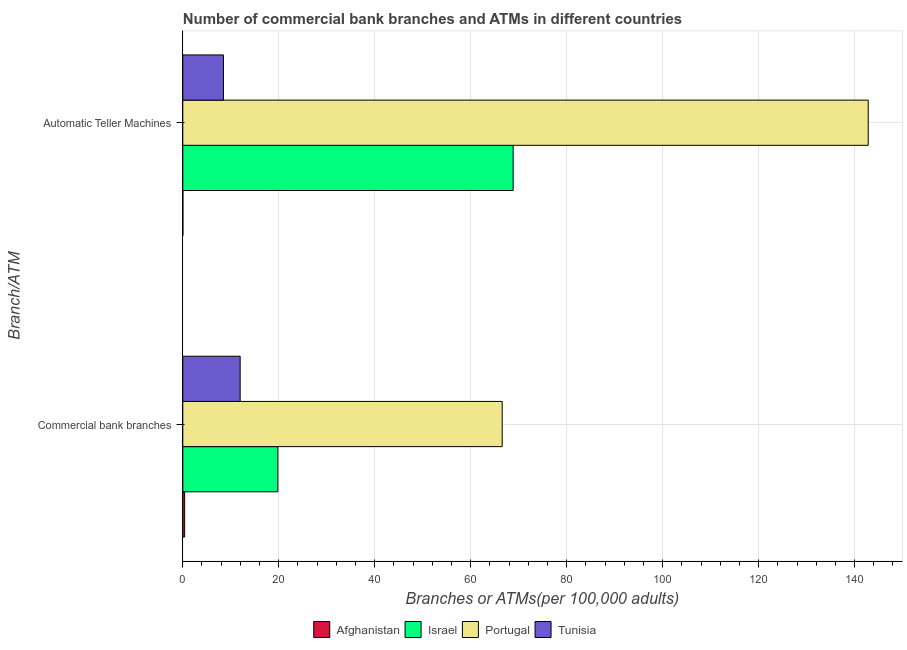Are the number of bars per tick equal to the number of legend labels?
Provide a succinct answer. Yes. What is the label of the 1st group of bars from the top?
Your answer should be compact. Automatic Teller Machines. What is the number of commercal bank branches in Afghanistan?
Keep it short and to the point. 0.39. Across all countries, what is the maximum number of commercal bank branches?
Provide a succinct answer. 66.56. Across all countries, what is the minimum number of atms?
Keep it short and to the point. 0.02. In which country was the number of commercal bank branches minimum?
Provide a succinct answer. Afghanistan. What is the total number of atms in the graph?
Give a very brief answer. 220.18. What is the difference between the number of commercal bank branches in Israel and that in Portugal?
Offer a terse response. -46.75. What is the difference between the number of atms in Afghanistan and the number of commercal bank branches in Israel?
Make the answer very short. -19.79. What is the average number of commercal bank branches per country?
Provide a succinct answer. 24.68. What is the difference between the number of commercal bank branches and number of atms in Tunisia?
Provide a succinct answer. 3.48. In how many countries, is the number of commercal bank branches greater than 8 ?
Provide a succinct answer. 3. What is the ratio of the number of commercal bank branches in Afghanistan to that in Portugal?
Your response must be concise. 0.01. Is the number of atms in Israel less than that in Afghanistan?
Your answer should be very brief. No. What does the 1st bar from the top in Automatic Teller Machines represents?
Give a very brief answer. Tunisia. What does the 4th bar from the bottom in Automatic Teller Machines represents?
Give a very brief answer. Tunisia. How many bars are there?
Ensure brevity in your answer.  8. Are the values on the major ticks of X-axis written in scientific E-notation?
Your answer should be compact. No. Does the graph contain any zero values?
Offer a terse response. No. How many legend labels are there?
Provide a succinct answer. 4. What is the title of the graph?
Ensure brevity in your answer.  Number of commercial bank branches and ATMs in different countries. What is the label or title of the X-axis?
Provide a short and direct response. Branches or ATMs(per 100,0 adults). What is the label or title of the Y-axis?
Provide a succinct answer. Branch/ATM. What is the Branches or ATMs(per 100,000 adults) of Afghanistan in Commercial bank branches?
Keep it short and to the point. 0.39. What is the Branches or ATMs(per 100,000 adults) in Israel in Commercial bank branches?
Give a very brief answer. 19.81. What is the Branches or ATMs(per 100,000 adults) of Portugal in Commercial bank branches?
Provide a short and direct response. 66.56. What is the Branches or ATMs(per 100,000 adults) in Tunisia in Commercial bank branches?
Keep it short and to the point. 11.95. What is the Branches or ATMs(per 100,000 adults) in Afghanistan in Automatic Teller Machines?
Your answer should be compact. 0.02. What is the Branches or ATMs(per 100,000 adults) of Israel in Automatic Teller Machines?
Offer a very short reply. 68.84. What is the Branches or ATMs(per 100,000 adults) in Portugal in Automatic Teller Machines?
Offer a terse response. 142.84. What is the Branches or ATMs(per 100,000 adults) in Tunisia in Automatic Teller Machines?
Offer a terse response. 8.48. Across all Branch/ATM, what is the maximum Branches or ATMs(per 100,000 adults) of Afghanistan?
Provide a succinct answer. 0.39. Across all Branch/ATM, what is the maximum Branches or ATMs(per 100,000 adults) of Israel?
Offer a very short reply. 68.84. Across all Branch/ATM, what is the maximum Branches or ATMs(per 100,000 adults) of Portugal?
Provide a succinct answer. 142.84. Across all Branch/ATM, what is the maximum Branches or ATMs(per 100,000 adults) of Tunisia?
Offer a very short reply. 11.95. Across all Branch/ATM, what is the minimum Branches or ATMs(per 100,000 adults) of Afghanistan?
Provide a short and direct response. 0.02. Across all Branch/ATM, what is the minimum Branches or ATMs(per 100,000 adults) of Israel?
Make the answer very short. 19.81. Across all Branch/ATM, what is the minimum Branches or ATMs(per 100,000 adults) of Portugal?
Ensure brevity in your answer.  66.56. Across all Branch/ATM, what is the minimum Branches or ATMs(per 100,000 adults) of Tunisia?
Give a very brief answer. 8.48. What is the total Branches or ATMs(per 100,000 adults) of Afghanistan in the graph?
Your answer should be very brief. 0.4. What is the total Branches or ATMs(per 100,000 adults) in Israel in the graph?
Make the answer very short. 88.65. What is the total Branches or ATMs(per 100,000 adults) of Portugal in the graph?
Provide a succinct answer. 209.41. What is the total Branches or ATMs(per 100,000 adults) of Tunisia in the graph?
Ensure brevity in your answer.  20.43. What is the difference between the Branches or ATMs(per 100,000 adults) of Afghanistan in Commercial bank branches and that in Automatic Teller Machines?
Provide a succinct answer. 0.37. What is the difference between the Branches or ATMs(per 100,000 adults) in Israel in Commercial bank branches and that in Automatic Teller Machines?
Your answer should be very brief. -49.04. What is the difference between the Branches or ATMs(per 100,000 adults) in Portugal in Commercial bank branches and that in Automatic Teller Machines?
Your response must be concise. -76.28. What is the difference between the Branches or ATMs(per 100,000 adults) of Tunisia in Commercial bank branches and that in Automatic Teller Machines?
Make the answer very short. 3.48. What is the difference between the Branches or ATMs(per 100,000 adults) of Afghanistan in Commercial bank branches and the Branches or ATMs(per 100,000 adults) of Israel in Automatic Teller Machines?
Keep it short and to the point. -68.46. What is the difference between the Branches or ATMs(per 100,000 adults) of Afghanistan in Commercial bank branches and the Branches or ATMs(per 100,000 adults) of Portugal in Automatic Teller Machines?
Offer a terse response. -142.46. What is the difference between the Branches or ATMs(per 100,000 adults) in Afghanistan in Commercial bank branches and the Branches or ATMs(per 100,000 adults) in Tunisia in Automatic Teller Machines?
Your answer should be very brief. -8.09. What is the difference between the Branches or ATMs(per 100,000 adults) in Israel in Commercial bank branches and the Branches or ATMs(per 100,000 adults) in Portugal in Automatic Teller Machines?
Your answer should be very brief. -123.03. What is the difference between the Branches or ATMs(per 100,000 adults) in Israel in Commercial bank branches and the Branches or ATMs(per 100,000 adults) in Tunisia in Automatic Teller Machines?
Offer a very short reply. 11.33. What is the difference between the Branches or ATMs(per 100,000 adults) of Portugal in Commercial bank branches and the Branches or ATMs(per 100,000 adults) of Tunisia in Automatic Teller Machines?
Offer a very short reply. 58.09. What is the average Branches or ATMs(per 100,000 adults) of Afghanistan per Branch/ATM?
Provide a short and direct response. 0.2. What is the average Branches or ATMs(per 100,000 adults) in Israel per Branch/ATM?
Offer a terse response. 44.33. What is the average Branches or ATMs(per 100,000 adults) in Portugal per Branch/ATM?
Provide a short and direct response. 104.7. What is the average Branches or ATMs(per 100,000 adults) of Tunisia per Branch/ATM?
Your answer should be very brief. 10.22. What is the difference between the Branches or ATMs(per 100,000 adults) of Afghanistan and Branches or ATMs(per 100,000 adults) of Israel in Commercial bank branches?
Provide a short and direct response. -19.42. What is the difference between the Branches or ATMs(per 100,000 adults) in Afghanistan and Branches or ATMs(per 100,000 adults) in Portugal in Commercial bank branches?
Your answer should be very brief. -66.18. What is the difference between the Branches or ATMs(per 100,000 adults) in Afghanistan and Branches or ATMs(per 100,000 adults) in Tunisia in Commercial bank branches?
Offer a terse response. -11.57. What is the difference between the Branches or ATMs(per 100,000 adults) of Israel and Branches or ATMs(per 100,000 adults) of Portugal in Commercial bank branches?
Offer a terse response. -46.75. What is the difference between the Branches or ATMs(per 100,000 adults) in Israel and Branches or ATMs(per 100,000 adults) in Tunisia in Commercial bank branches?
Give a very brief answer. 7.86. What is the difference between the Branches or ATMs(per 100,000 adults) of Portugal and Branches or ATMs(per 100,000 adults) of Tunisia in Commercial bank branches?
Give a very brief answer. 54.61. What is the difference between the Branches or ATMs(per 100,000 adults) in Afghanistan and Branches or ATMs(per 100,000 adults) in Israel in Automatic Teller Machines?
Your answer should be compact. -68.83. What is the difference between the Branches or ATMs(per 100,000 adults) of Afghanistan and Branches or ATMs(per 100,000 adults) of Portugal in Automatic Teller Machines?
Offer a terse response. -142.83. What is the difference between the Branches or ATMs(per 100,000 adults) of Afghanistan and Branches or ATMs(per 100,000 adults) of Tunisia in Automatic Teller Machines?
Keep it short and to the point. -8.46. What is the difference between the Branches or ATMs(per 100,000 adults) of Israel and Branches or ATMs(per 100,000 adults) of Portugal in Automatic Teller Machines?
Offer a very short reply. -74. What is the difference between the Branches or ATMs(per 100,000 adults) in Israel and Branches or ATMs(per 100,000 adults) in Tunisia in Automatic Teller Machines?
Offer a very short reply. 60.37. What is the difference between the Branches or ATMs(per 100,000 adults) of Portugal and Branches or ATMs(per 100,000 adults) of Tunisia in Automatic Teller Machines?
Give a very brief answer. 134.37. What is the ratio of the Branches or ATMs(per 100,000 adults) of Israel in Commercial bank branches to that in Automatic Teller Machines?
Give a very brief answer. 0.29. What is the ratio of the Branches or ATMs(per 100,000 adults) in Portugal in Commercial bank branches to that in Automatic Teller Machines?
Provide a short and direct response. 0.47. What is the ratio of the Branches or ATMs(per 100,000 adults) of Tunisia in Commercial bank branches to that in Automatic Teller Machines?
Make the answer very short. 1.41. What is the difference between the highest and the second highest Branches or ATMs(per 100,000 adults) of Afghanistan?
Your answer should be compact. 0.37. What is the difference between the highest and the second highest Branches or ATMs(per 100,000 adults) of Israel?
Your response must be concise. 49.04. What is the difference between the highest and the second highest Branches or ATMs(per 100,000 adults) in Portugal?
Offer a very short reply. 76.28. What is the difference between the highest and the second highest Branches or ATMs(per 100,000 adults) in Tunisia?
Your response must be concise. 3.48. What is the difference between the highest and the lowest Branches or ATMs(per 100,000 adults) in Afghanistan?
Give a very brief answer. 0.37. What is the difference between the highest and the lowest Branches or ATMs(per 100,000 adults) of Israel?
Give a very brief answer. 49.04. What is the difference between the highest and the lowest Branches or ATMs(per 100,000 adults) in Portugal?
Offer a very short reply. 76.28. What is the difference between the highest and the lowest Branches or ATMs(per 100,000 adults) in Tunisia?
Your response must be concise. 3.48. 